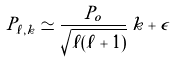Convert formula to latex. <formula><loc_0><loc_0><loc_500><loc_500>P _ { \ell , k } \simeq \frac { P _ { o } } { \sqrt { \ell ( \ell + 1 ) } } \, k + \epsilon</formula> 